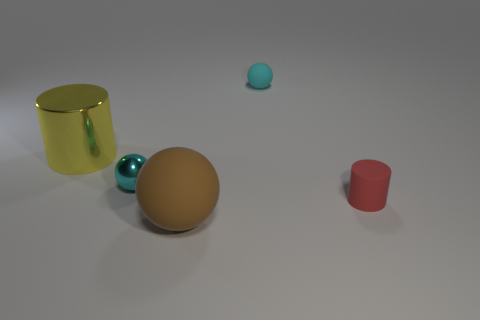Add 2 tiny purple matte cylinders. How many objects exist? 7 Subtract all cylinders. How many objects are left? 3 Add 1 tiny purple metal spheres. How many tiny purple metal spheres exist? 1 Subtract 0 yellow cubes. How many objects are left? 5 Subtract all big blue metal balls. Subtract all spheres. How many objects are left? 2 Add 1 spheres. How many spheres are left? 4 